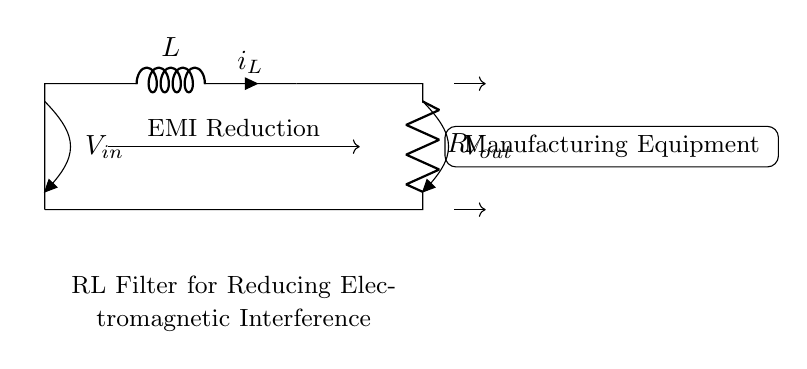What is the value of the inductor in the circuit? The value of the inductor is indicated by the label "L" in the circuit diagram, though the exact value is not specified.
Answer: L What does the "R" represent in the circuit? The "R" in the circuit represents a resistor, which is a component that restricts current flow.
Answer: Resistor What type of filter is represented by this circuit? This circuit represents an RL filter, specifically designed for reducing electromagnetic interference (EMI).
Answer: RL filter What is the primary purpose of this RL filter? The primary purpose of the RL filter is indicated by the label "EMI Reduction" in the circuit, which shows that it is intended to minimize electromagnetic interference in manufacturing equipment.
Answer: EMI Reduction How are the components in the circuit connected? The components, inductor and resistor, are connected in series, forming a single pathway for current to flow through both components.
Answer: In series What happens to the output voltage when the input voltage fluctuates? When the input voltage fluctuates, the output voltage will smooth out variations due to the filtering action of the inductor and resistor combination, resulting in reduced EMI at the output.
Answer: Smooths out What does the arrow indicate in relation to the current direction? The arrows, labeled "i_L", indicate the direction of the current flowing through the inductor, showing the expected current path in the circuit.
Answer: Current direction 